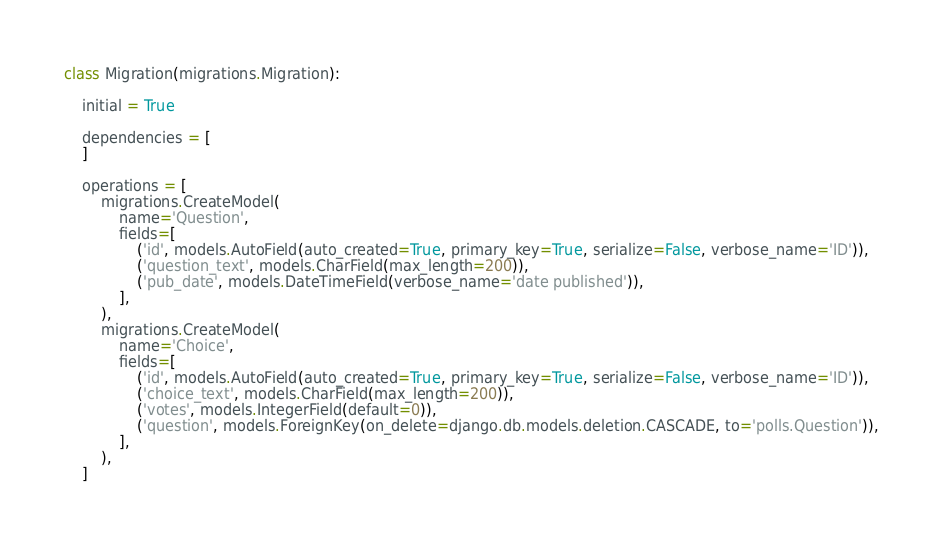Convert code to text. <code><loc_0><loc_0><loc_500><loc_500><_Python_>class Migration(migrations.Migration):

    initial = True

    dependencies = [
    ]

    operations = [
        migrations.CreateModel(
            name='Question',
            fields=[
                ('id', models.AutoField(auto_created=True, primary_key=True, serialize=False, verbose_name='ID')),
                ('question_text', models.CharField(max_length=200)),
                ('pub_date', models.DateTimeField(verbose_name='date published')),
            ],
        ),
        migrations.CreateModel(
            name='Choice',
            fields=[
                ('id', models.AutoField(auto_created=True, primary_key=True, serialize=False, verbose_name='ID')),
                ('choice_text', models.CharField(max_length=200)),
                ('votes', models.IntegerField(default=0)),
                ('question', models.ForeignKey(on_delete=django.db.models.deletion.CASCADE, to='polls.Question')),
            ],
        ),
    ]
</code> 